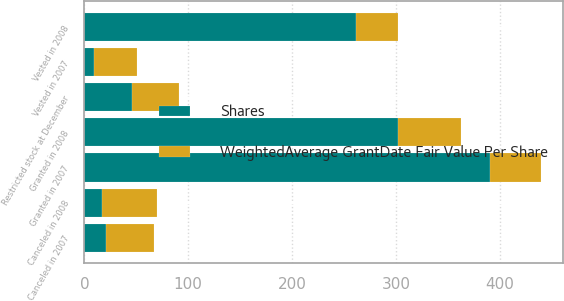Convert chart to OTSL. <chart><loc_0><loc_0><loc_500><loc_500><stacked_bar_chart><ecel><fcel>Restricted stock at December<fcel>Granted in 2007<fcel>Canceled in 2007<fcel>Vested in 2007<fcel>Granted in 2008<fcel>Canceled in 2008<fcel>Vested in 2008<nl><fcel>Shares<fcel>45.88<fcel>391<fcel>21<fcel>9<fcel>302<fcel>17<fcel>262<nl><fcel>WeightedAverage GrantDate Fair Value Per Share<fcel>45.65<fcel>48.43<fcel>45.88<fcel>42.06<fcel>61<fcel>52.86<fcel>39.95<nl></chart> 